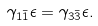<formula> <loc_0><loc_0><loc_500><loc_500>\gamma _ { 1 \bar { 1 } } \epsilon = \gamma _ { 3 \bar { 3 } } \epsilon .</formula> 